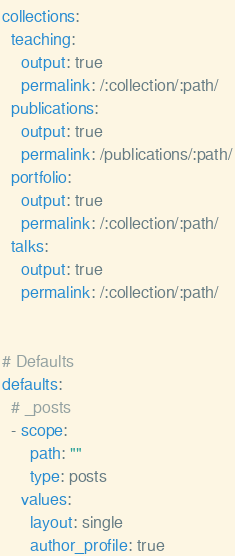Convert code to text. <code><loc_0><loc_0><loc_500><loc_500><_YAML_>collections:
  teaching:
    output: true
    permalink: /:collection/:path/
  publications:
    output: true
    permalink: /publications/:path/
  portfolio:
    output: true
    permalink: /:collection/:path/
  talks:
    output: true
    permalink: /:collection/:path/


# Defaults
defaults:
  # _posts
  - scope:
      path: ""
      type: posts
    values:
      layout: single
      author_profile: true</code> 